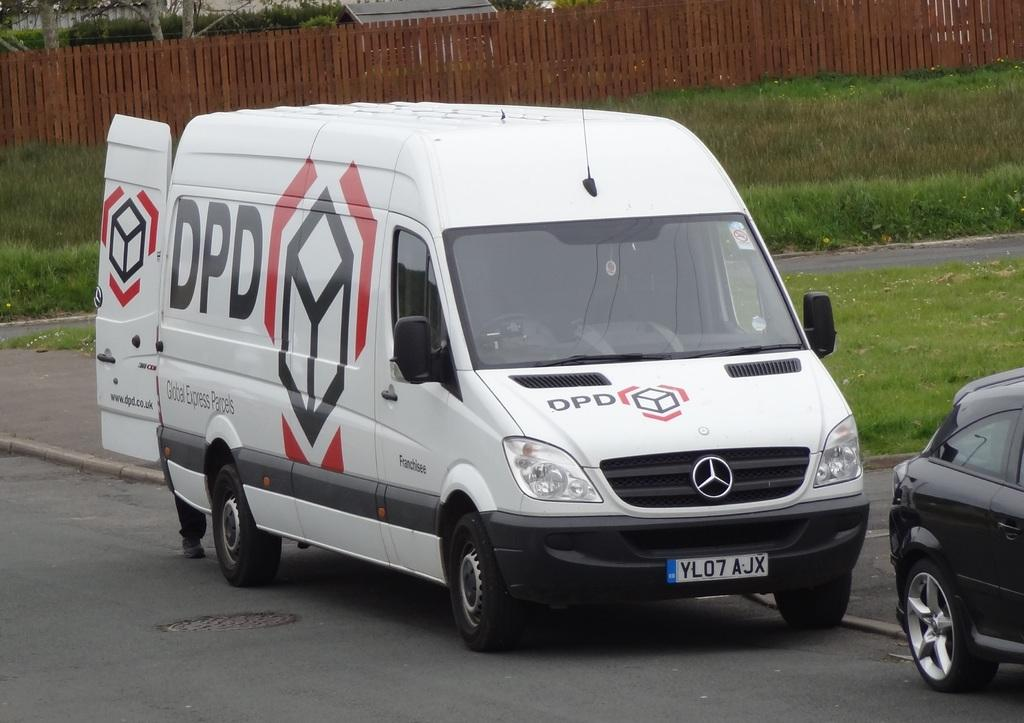<image>
Render a clear and concise summary of the photo. A white van has the text DPd displayed on its side and front hood. 